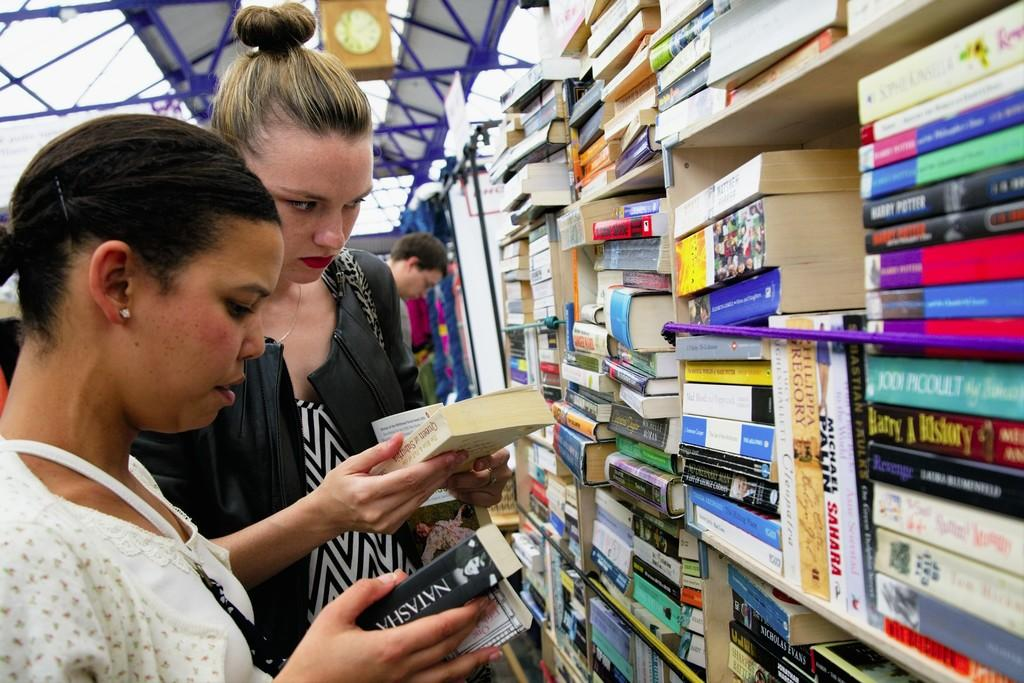Provide a one-sentence caption for the provided image. A woman looks at a book with the name Natasha on the spine, while her friend looks at a different book. 